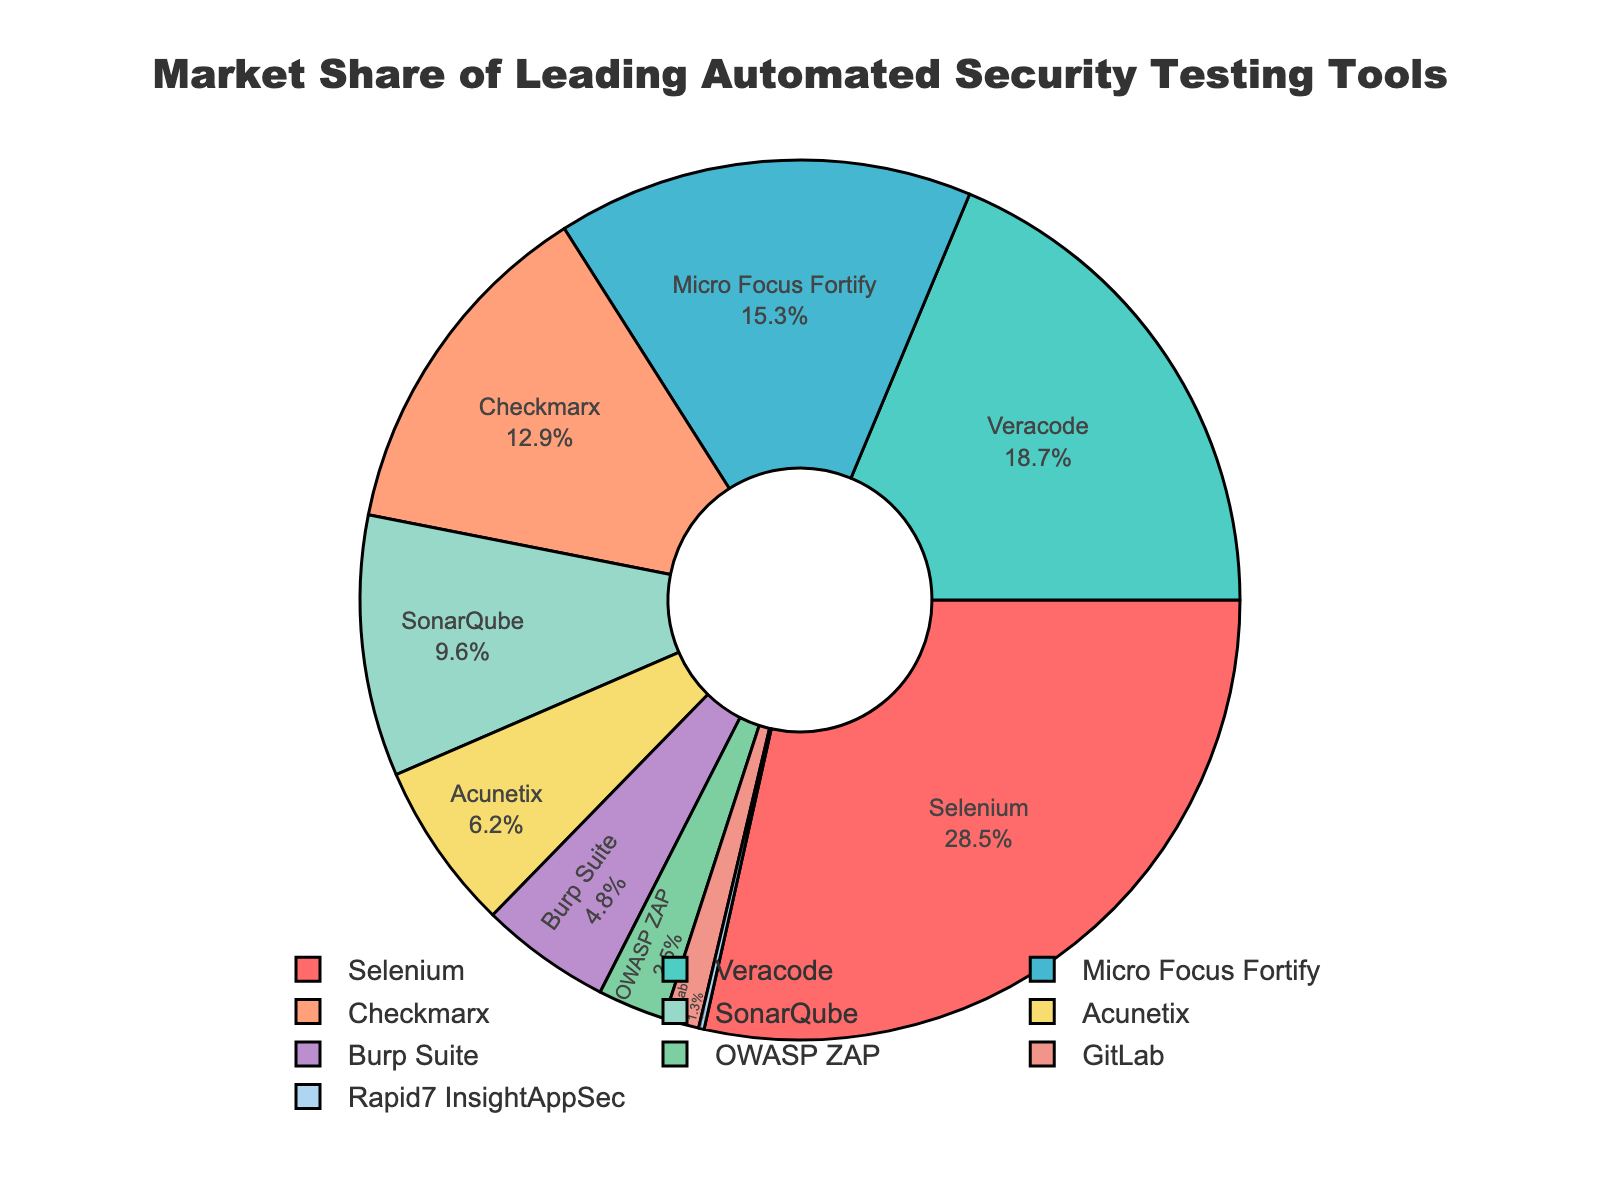What percentage of the market share is held by the top three tools combined? First, identify the market share percentages of the top three tools: Selenium (28.5%), Veracode (18.7%), and Micro Focus Fortify (15.3%). Sum these percentages: 28.5 + 18.7 + 15.3 = 62.5%.
Answer: 62.5% Which tool has a lower market share, OWASP ZAP or GitLab? By how much? First, identify the market share percentages: OWASP ZAP (2.5%) and GitLab (1.3%). Subtract GitLab's share from OWASP ZAP's: 2.5 - 1.3 = 1.2%.
Answer: OWASP ZAP, 1.2% Among the tools with less than 10% market share, which one has the highest percentage? Identify the tools with less than 10% market share: SonarQube (9.6%), Acunetix (6.2%), Burp Suite (4.8%), OWASP ZAP (2.5%), GitLab (1.3%), and Rapid7 InsightAppSec (0.2%). Among these, SonarQube has the highest percentage at 9.6%.
Answer: SonarQube How much larger is Selenium's market share compared to Checkmarx's? Identify the market share percentages: Selenium (28.5%) and Checkmarx (12.9%). Subtract Checkmarx's share from Selenium's: 28.5 - 12.9 = 15.6%.
Answer: 15.6% What is the average market share of Micro Focus Fortify, Checkmarx, and SonarQube? Identify the market share percentages: Micro Focus Fortify (15.3%), Checkmarx (12.9%), and SonarQube (9.6%). Calculate the average: (15.3 + 12.9 + 9.6) / 3 = 12.6%.
Answer: 12.6% Which segment is visually the largest in the pie chart? By examining the pie chart, the largest segment is the one representing Selenium with a market share of 28.5%.
Answer: Selenium Is the cumulative market share of Burp Suite and Acunetix greater than 10%? Identify the market share percentages: Burp Suite (4.8%) and Acunetix (6.2%). Sum these percentages: 4.8 + 6.2 = 11%. Since 11% is greater than 10%, the cumulative share is indeed greater.
Answer: Yes If the pie chart is rotated 180 degrees, which tool's segment is at the topmost position? Initially, the pie chart's rotation starts at 90 degrees, which means the first segment at the topmost position, when rotated by 180 degrees further, would be the segment that was previously at the bottom. This would be SonarQube with a market share of 9.6%.
Answer: SonarQube What is the total market share of tools with a market share of 5% or less? Identify the tools with 5% or less: Burp Suite (4.8%), OWASP ZAP (2.5%), GitLab (1.3%), and Rapid7 InsightAppSec (0.2%). Sum these percentages: 4.8 + 2.5 + 1.3 + 0.2 = 8.8%.
Answer: 8.8% 